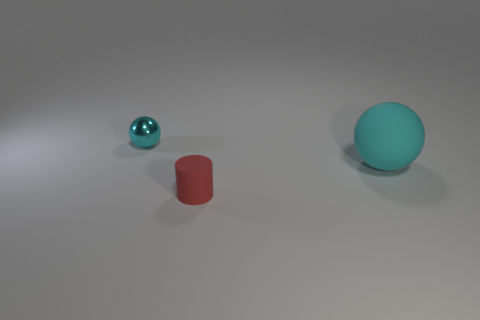Are there any other things that have the same size as the cyan rubber thing?
Your answer should be compact. No. Does the small thing that is in front of the small cyan sphere have the same material as the small sphere that is behind the matte cylinder?
Give a very brief answer. No. Is there anything else that is the same shape as the tiny red object?
Make the answer very short. No. What color is the big rubber ball?
Provide a short and direct response. Cyan. How many cyan matte objects have the same shape as the cyan metallic object?
Your response must be concise. 1. There is a cylinder that is the same size as the cyan shiny object; what is its color?
Keep it short and to the point. Red. Are there any tiny metallic spheres?
Provide a succinct answer. Yes. There is a tiny object that is behind the large cyan matte thing; what is its shape?
Make the answer very short. Sphere. What number of objects are both in front of the tiny cyan thing and to the left of the big cyan ball?
Make the answer very short. 1. Is there a tiny object made of the same material as the big thing?
Your answer should be compact. Yes. 